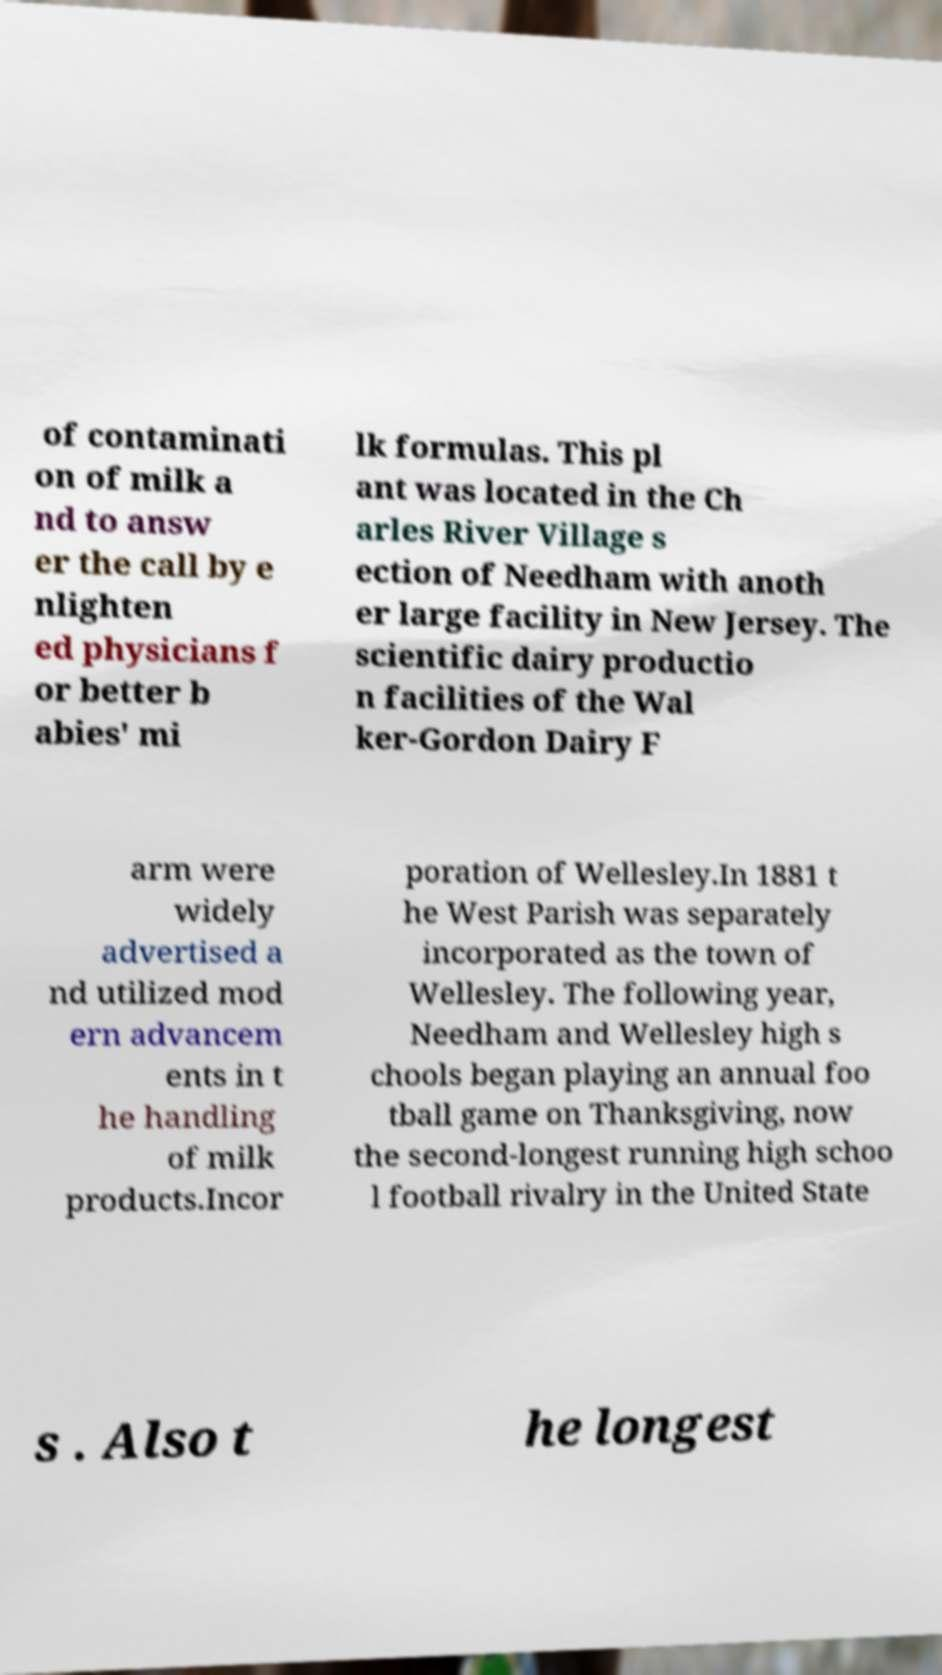Can you read and provide the text displayed in the image?This photo seems to have some interesting text. Can you extract and type it out for me? of contaminati on of milk a nd to answ er the call by e nlighten ed physicians f or better b abies' mi lk formulas. This pl ant was located in the Ch arles River Village s ection of Needham with anoth er large facility in New Jersey. The scientific dairy productio n facilities of the Wal ker-Gordon Dairy F arm were widely advertised a nd utilized mod ern advancem ents in t he handling of milk products.Incor poration of Wellesley.In 1881 t he West Parish was separately incorporated as the town of Wellesley. The following year, Needham and Wellesley high s chools began playing an annual foo tball game on Thanksgiving, now the second-longest running high schoo l football rivalry in the United State s . Also t he longest 